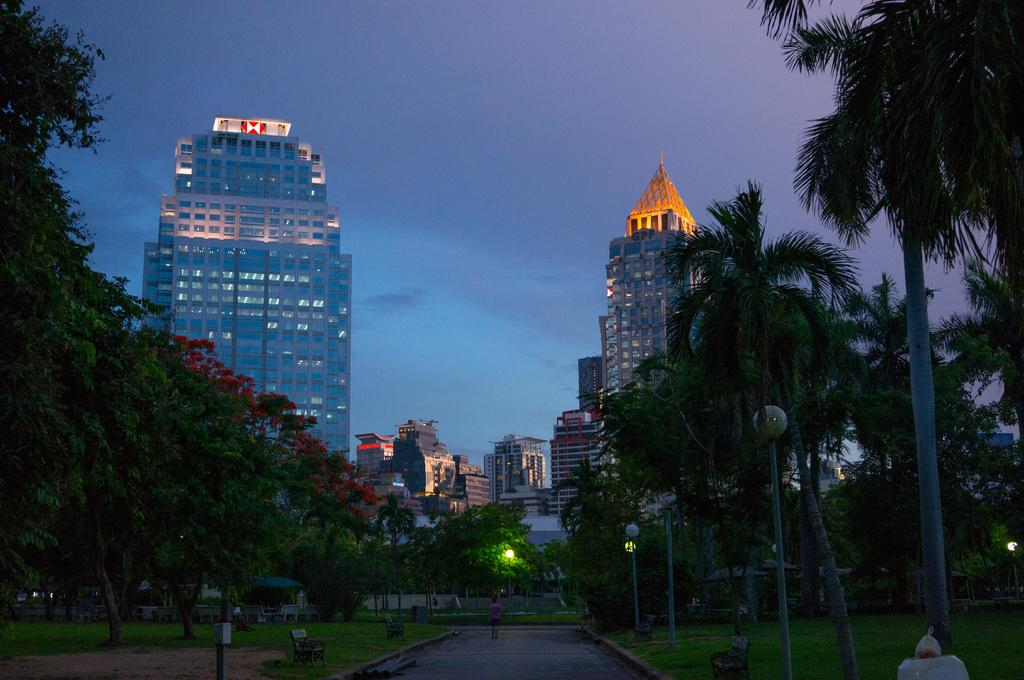What type of vegetation can be seen in the garden in the image? There are trees in the garden in the image. Can you describe the trees on the right side of the image? There are coconut trees on the right side of the image. What else can be seen on the right side of the image? There are light poles on the right side of the image. What is visible in the background of the image? There is a big building in the background of the image. What feature of the building is visible? There are glass windows visible on the building. How many dimes are scattered on the ground in the image? There are no dimes present in the image; it features trees, coconut trees, light poles, a big building, and glass windows. What type of books can be seen on the trees in the image? There are no books present in the image, as it features trees, coconut trees, light poles, a big building, and glass windows. 